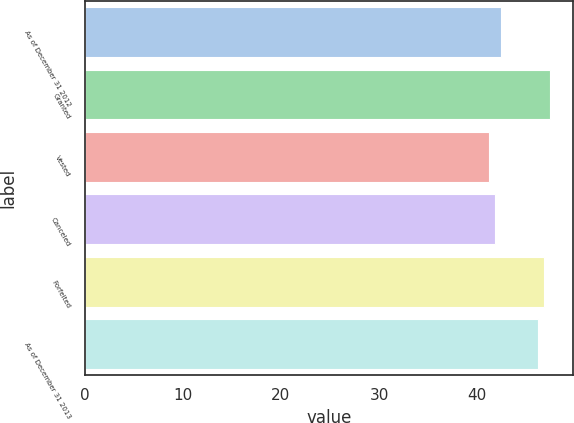<chart> <loc_0><loc_0><loc_500><loc_500><bar_chart><fcel>As of December 31 2012<fcel>Granted<fcel>Vested<fcel>Canceled<fcel>Forfeited<fcel>As of December 31 2013<nl><fcel>42.38<fcel>47.4<fcel>41.16<fcel>41.77<fcel>46.79<fcel>46.18<nl></chart> 